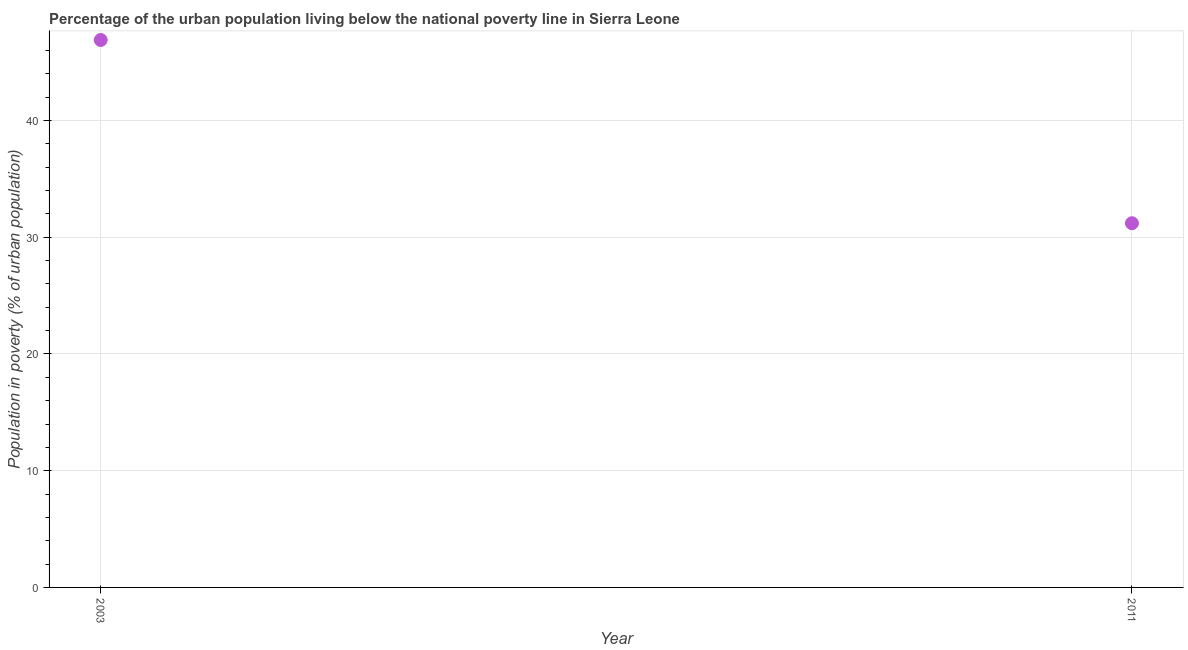What is the percentage of urban population living below poverty line in 2003?
Make the answer very short. 46.9. Across all years, what is the maximum percentage of urban population living below poverty line?
Keep it short and to the point. 46.9. Across all years, what is the minimum percentage of urban population living below poverty line?
Offer a very short reply. 31.2. In which year was the percentage of urban population living below poverty line minimum?
Keep it short and to the point. 2011. What is the sum of the percentage of urban population living below poverty line?
Provide a succinct answer. 78.1. What is the difference between the percentage of urban population living below poverty line in 2003 and 2011?
Your answer should be compact. 15.7. What is the average percentage of urban population living below poverty line per year?
Make the answer very short. 39.05. What is the median percentage of urban population living below poverty line?
Provide a short and direct response. 39.05. What is the ratio of the percentage of urban population living below poverty line in 2003 to that in 2011?
Your answer should be very brief. 1.5. Is the percentage of urban population living below poverty line in 2003 less than that in 2011?
Give a very brief answer. No. In how many years, is the percentage of urban population living below poverty line greater than the average percentage of urban population living below poverty line taken over all years?
Keep it short and to the point. 1. How many dotlines are there?
Keep it short and to the point. 1. How many years are there in the graph?
Keep it short and to the point. 2. Does the graph contain any zero values?
Your answer should be compact. No. What is the title of the graph?
Your answer should be compact. Percentage of the urban population living below the national poverty line in Sierra Leone. What is the label or title of the Y-axis?
Your response must be concise. Population in poverty (% of urban population). What is the Population in poverty (% of urban population) in 2003?
Give a very brief answer. 46.9. What is the Population in poverty (% of urban population) in 2011?
Offer a terse response. 31.2. What is the ratio of the Population in poverty (% of urban population) in 2003 to that in 2011?
Your response must be concise. 1.5. 